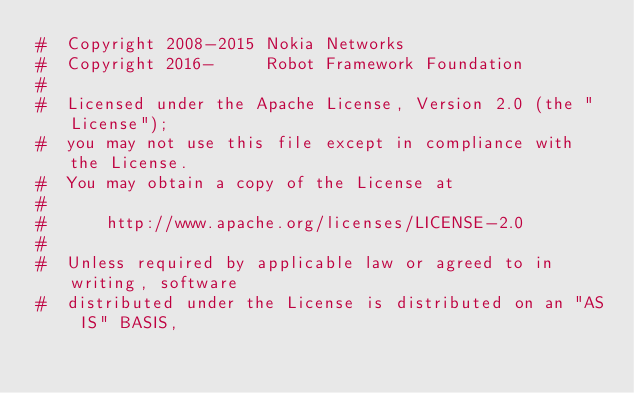<code> <loc_0><loc_0><loc_500><loc_500><_Python_>#  Copyright 2008-2015 Nokia Networks
#  Copyright 2016-     Robot Framework Foundation
#
#  Licensed under the Apache License, Version 2.0 (the "License");
#  you may not use this file except in compliance with the License.
#  You may obtain a copy of the License at
#
#      http://www.apache.org/licenses/LICENSE-2.0
#
#  Unless required by applicable law or agreed to in writing, software
#  distributed under the License is distributed on an "AS IS" BASIS,</code> 